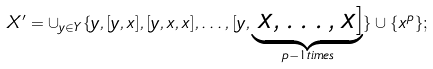Convert formula to latex. <formula><loc_0><loc_0><loc_500><loc_500>X ^ { \prime } = \cup _ { y \in Y } \{ y , [ y , x ] , [ y , x , x ] , \dots , [ y , \underbrace { \, x , \dots , x ] } _ { p - 1 t i m e s } \} \cup \{ x ^ { p } \} ;</formula> 